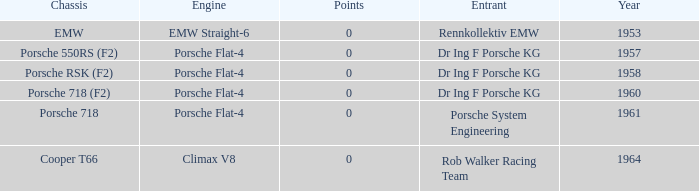What engine did the porsche 718 chassis use? Porsche Flat-4. 